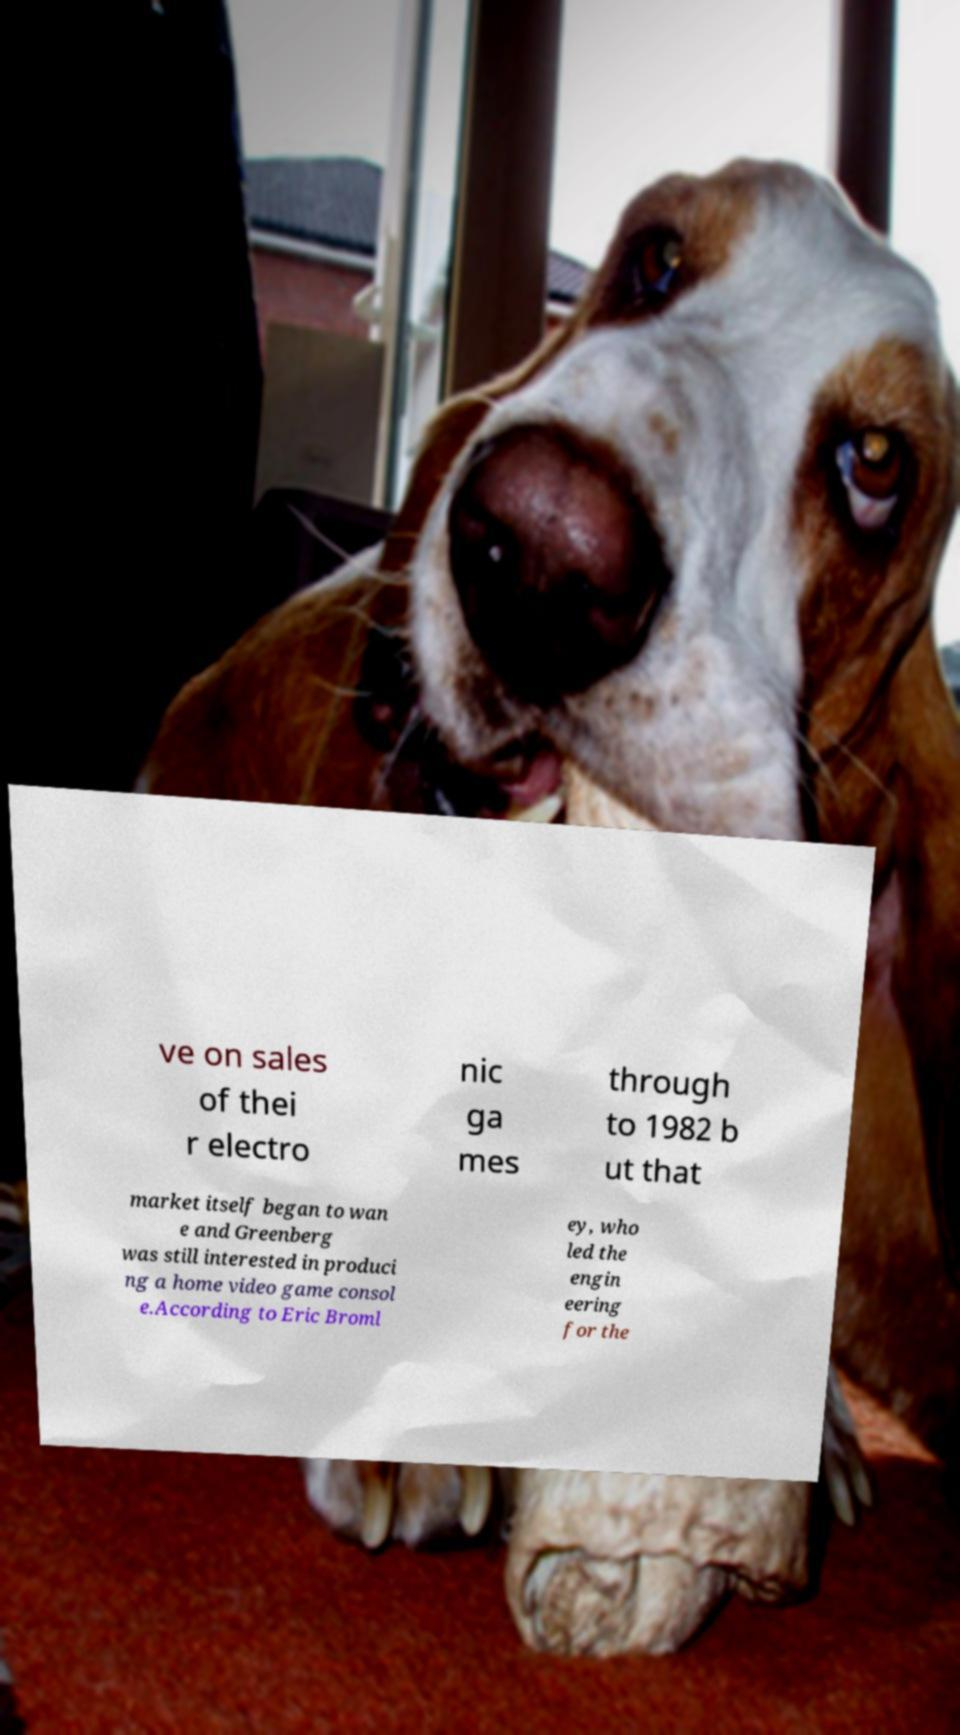For documentation purposes, I need the text within this image transcribed. Could you provide that? ve on sales of thei r electro nic ga mes through to 1982 b ut that market itself began to wan e and Greenberg was still interested in produci ng a home video game consol e.According to Eric Broml ey, who led the engin eering for the 